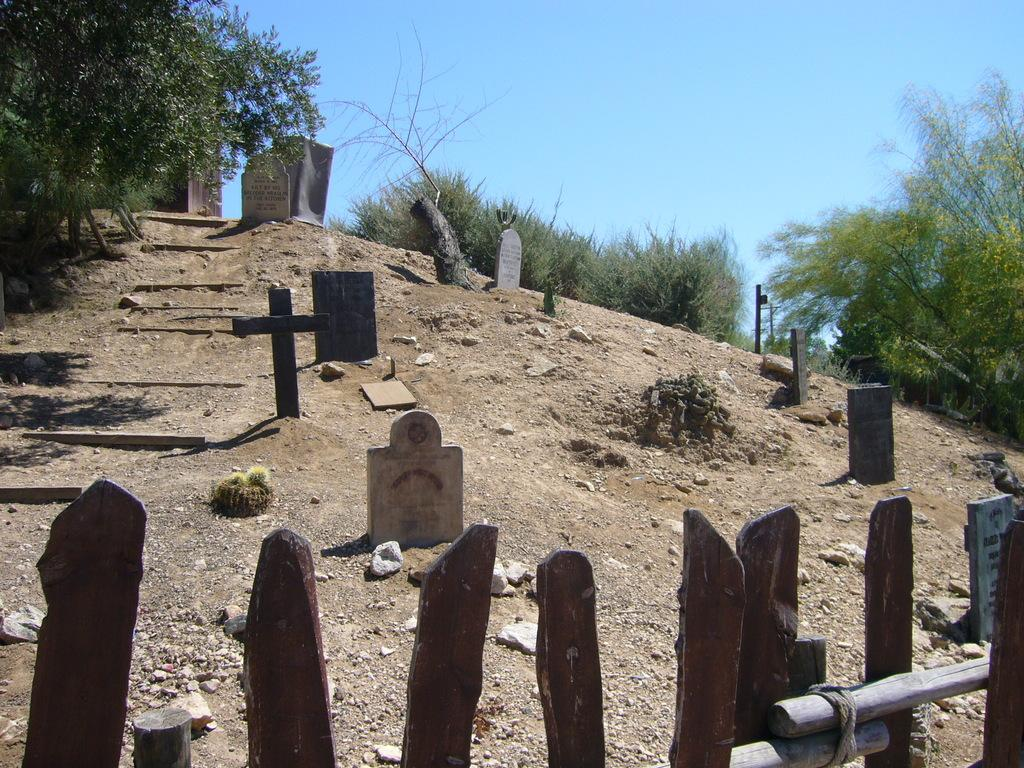What type of location is depicted in the image? There is a graveyard in the image. What natural elements can be seen in the image? There are rocks and trees in the image. What is the color of the sky in the image? The sky is blue in the image. How does the addition of a new rock affect the image? There is no indication of any changes or additions to the image, so it cannot be determined how the addition of a new rock would affect it. Was there an earthquake in the image? There is no indication of an earthquake or any seismic activity in the image. 